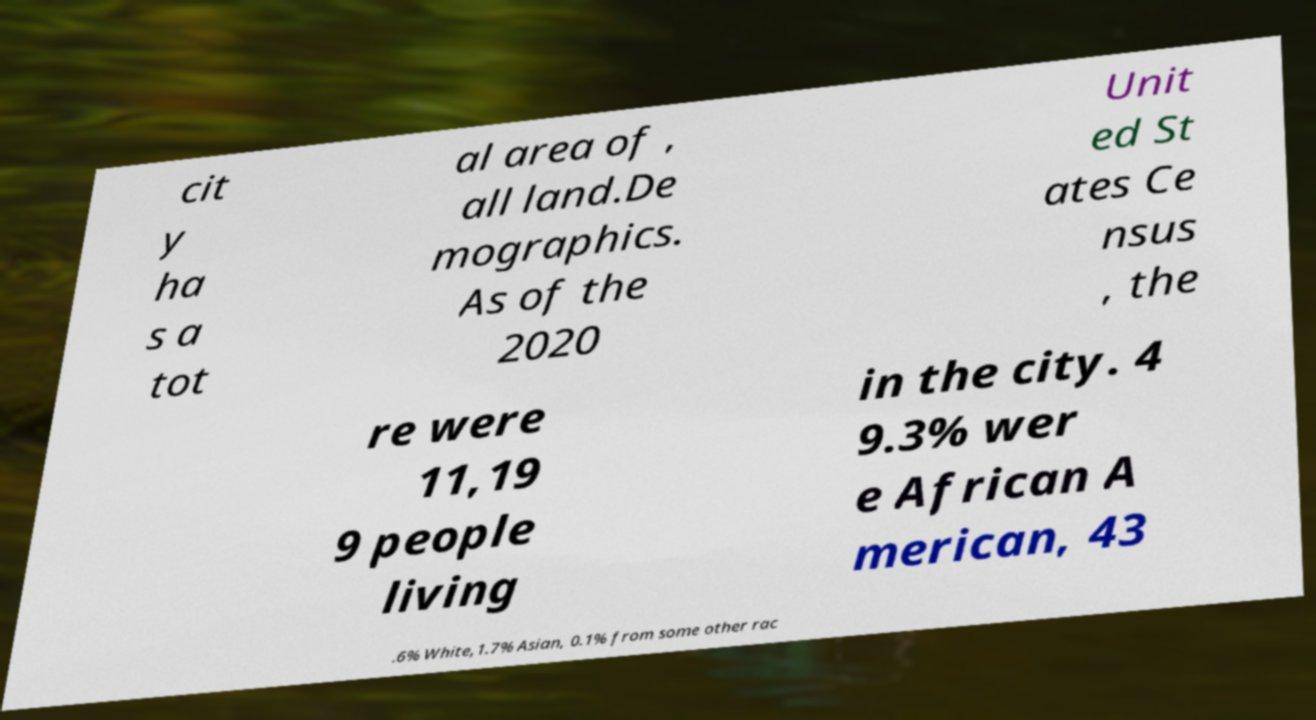Please read and relay the text visible in this image. What does it say? cit y ha s a tot al area of , all land.De mographics. As of the 2020 Unit ed St ates Ce nsus , the re were 11,19 9 people living in the city. 4 9.3% wer e African A merican, 43 .6% White,1.7% Asian, 0.1% from some other rac 